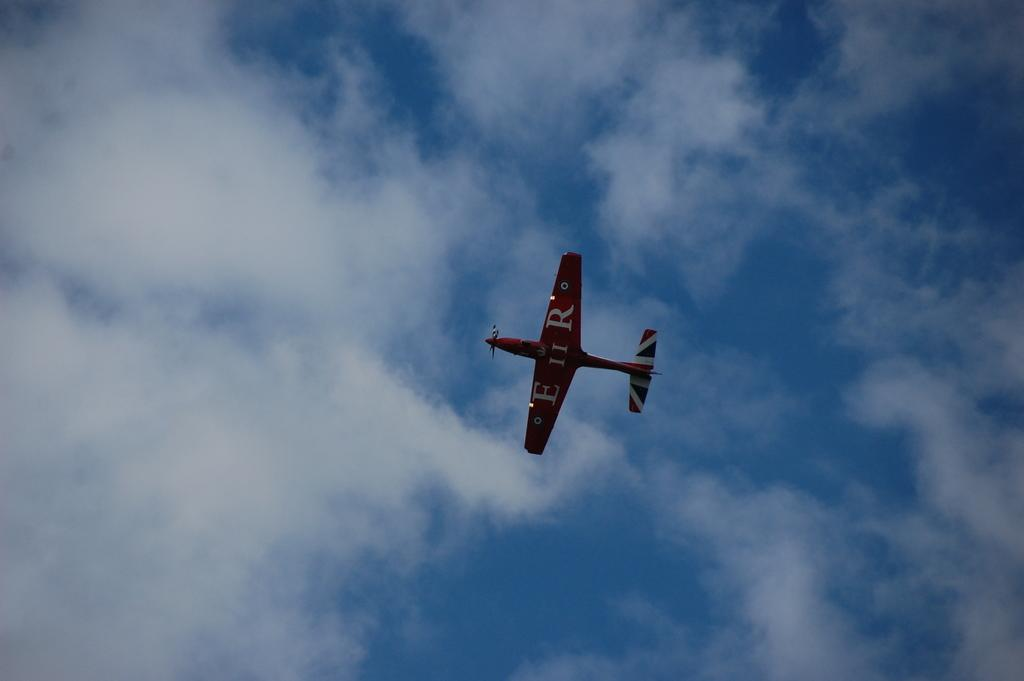What is the main subject of the image? The main subject of the image is an airplane. What is the airplane doing in the image? The airplane is flying in the air. What can be seen in the sky in the image? There are clouds visible in the sky. What type of statement can be seen written on the lake in the image? There is no lake or statement present in the image; it features an airplane flying in the sky with clouds visible. 